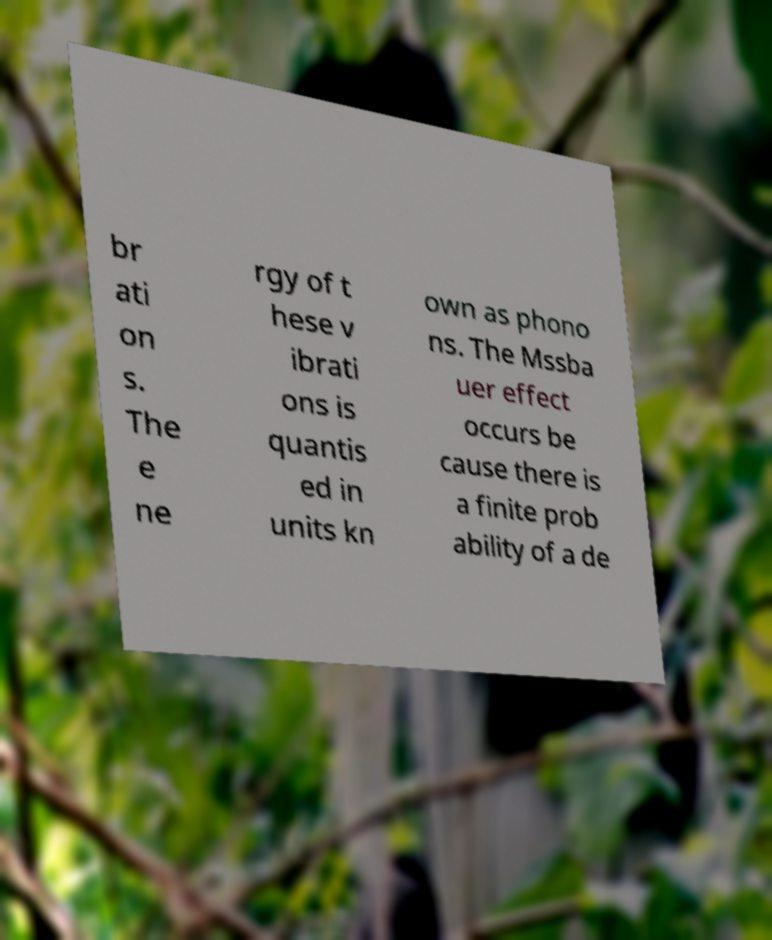I need the written content from this picture converted into text. Can you do that? br ati on s. The e ne rgy of t hese v ibrati ons is quantis ed in units kn own as phono ns. The Mssba uer effect occurs be cause there is a finite prob ability of a de 